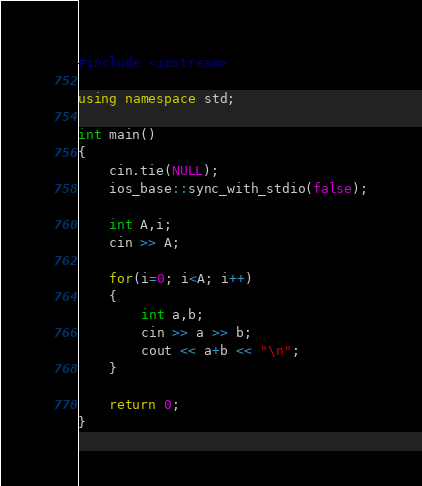Convert code to text. <code><loc_0><loc_0><loc_500><loc_500><_C++_>#include <iostream>

using namespace std;

int main()
{
    cin.tie(NULL);
    ios_base::sync_with_stdio(false);

    int A,i;
    cin >> A;

    for(i=0; i<A; i++)
    {
        int a,b;
        cin >> a >> b;
        cout << a+b << "\n";
    }

    return 0;
}</code> 